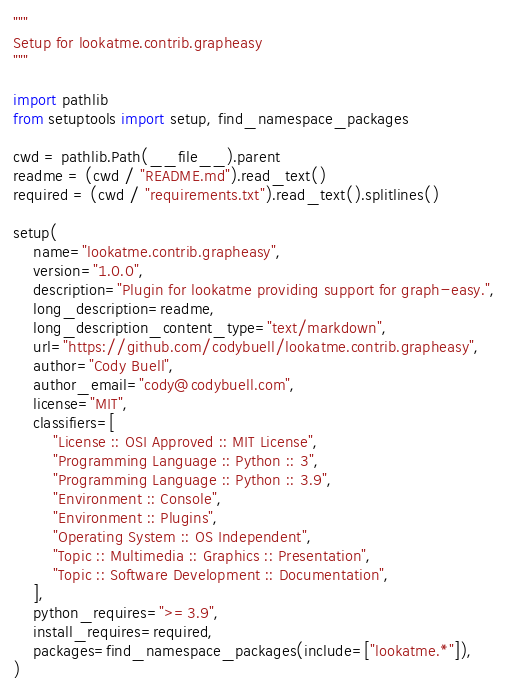Convert code to text. <code><loc_0><loc_0><loc_500><loc_500><_Python_>"""
Setup for lookatme.contrib.grapheasy
"""

import pathlib
from setuptools import setup, find_namespace_packages

cwd = pathlib.Path(__file__).parent
readme = (cwd / "README.md").read_text()
required = (cwd / "requirements.txt").read_text().splitlines()

setup(
    name="lookatme.contrib.grapheasy",
    version="1.0.0",
    description="Plugin for lookatme providing support for graph-easy.",
    long_description=readme,
    long_description_content_type="text/markdown",
    url="https://github.com/codybuell/lookatme.contrib.grapheasy",
    author="Cody Buell",
    author_email="cody@codybuell.com",
    license="MIT",
    classifiers=[
        "License :: OSI Approved :: MIT License",
        "Programming Language :: Python :: 3",
        "Programming Language :: Python :: 3.9",
        "Environment :: Console",
        "Environment :: Plugins",
        "Operating System :: OS Independent",
        "Topic :: Multimedia :: Graphics :: Presentation",
        "Topic :: Software Development :: Documentation",
    ],
    python_requires=">=3.9",
    install_requires=required,
    packages=find_namespace_packages(include=["lookatme.*"]),
)
</code> 